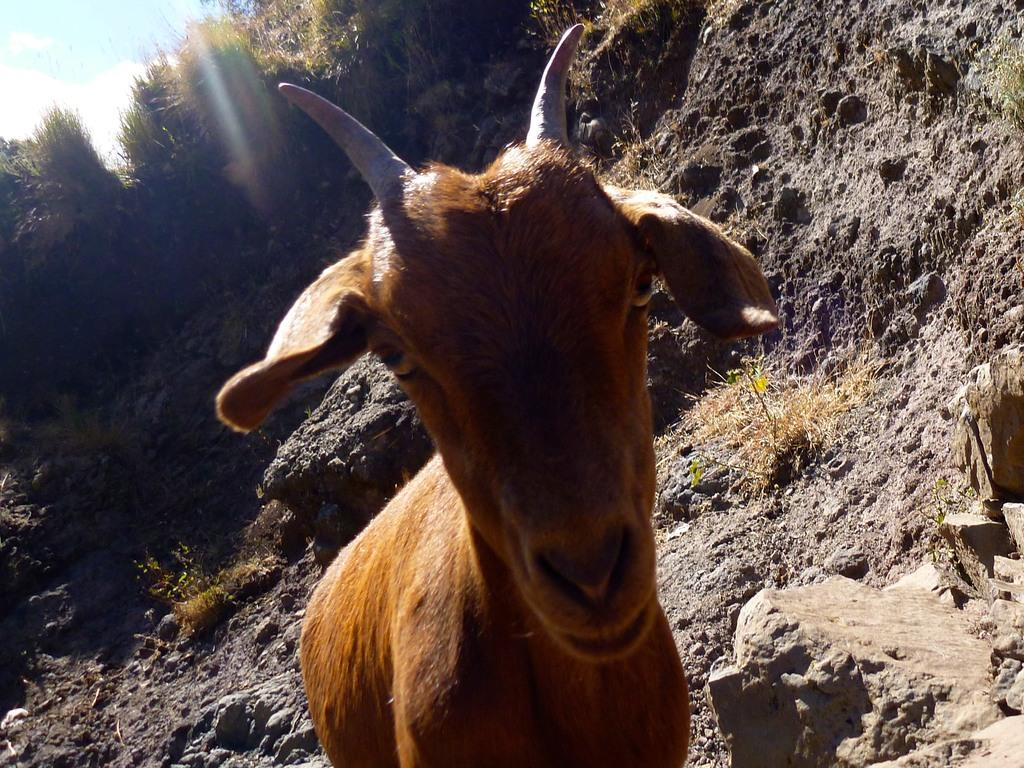What type of animal can be seen in the image? There is an animal in the image, but its specific type cannot be determined from the provided facts. What color is the animal in the image? The animal is brown in color. What can be seen in the background of the image? There are trees in the background of the image. What color are the trees in the image? The trees are green in color. What is visible above the trees in the image? The sky is visible in the image. What colors can be seen in the sky in the image? The sky has both white and blue colors. What type of skirt is the animal wearing in the image? There is no skirt present in the image, as the animal is not a human and does not wear clothing. 